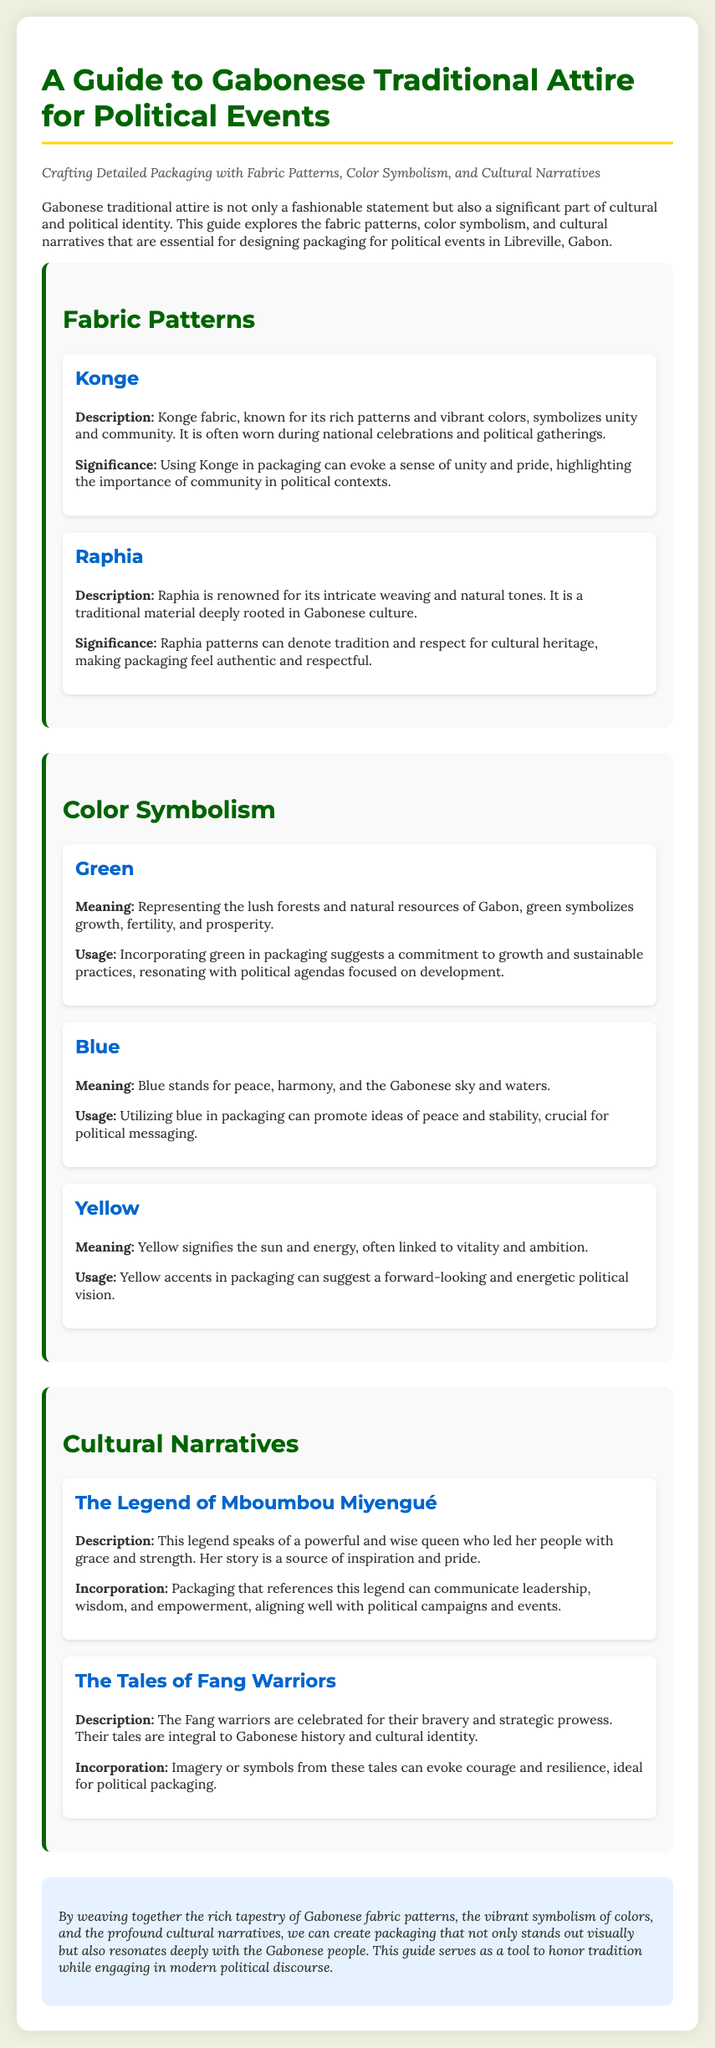What is the title of the guide? The title is stated prominently at the beginning of the document.
Answer: A Guide to Gabonese Traditional Attire for Political Events What fabric is known for its rich patterns and vibrant colors? This information is found in the "Fabric Patterns" section describing Konge.
Answer: Konge What color symbolizes growth, fertility, and prosperity? The section on color symbolism mentions this color clearly.
Answer: Green What legend is referenced in the cultural narratives? The cultural narratives section discusses this legend explicitly.
Answer: The Legend of Mboumbou Miyengué What does Raphia symbolize? The significance of Raphia is explained in the related section about fabric patterns.
Answer: Tradition and respect for cultural heritage How many colors are discussed in the Color Symbolism section? The document lists various colors under this section.
Answer: Three What narrative promotes concepts of leadership and empowerment? The cultural narrative section highlights this particular narrative.
Answer: The Legend of Mboumbou Miyengué What does blue symbolize in Gabonese culture? The meaning of the color blue is detailed in the document under color symbolism.
Answer: Peace, harmony What is the significance of using Konge in packaging? The explanation of the significance is found in the fabric patterns section.
Answer: Evoke a sense of unity and pride 